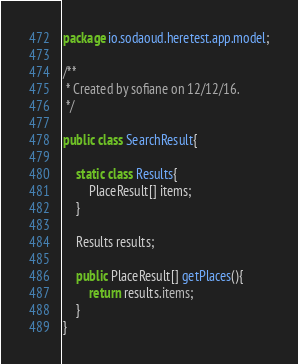<code> <loc_0><loc_0><loc_500><loc_500><_Java_>package io.sodaoud.heretest.app.model;

/**
 * Created by sofiane on 12/12/16.
 */

public class SearchResult{

    static class Results{
        PlaceResult[] items;
    }

    Results results;

    public PlaceResult[] getPlaces(){
        return results.items;
    }
}
</code> 